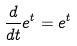Convert formula to latex. <formula><loc_0><loc_0><loc_500><loc_500>\frac { d } { d t } e ^ { t } = e ^ { t }</formula> 